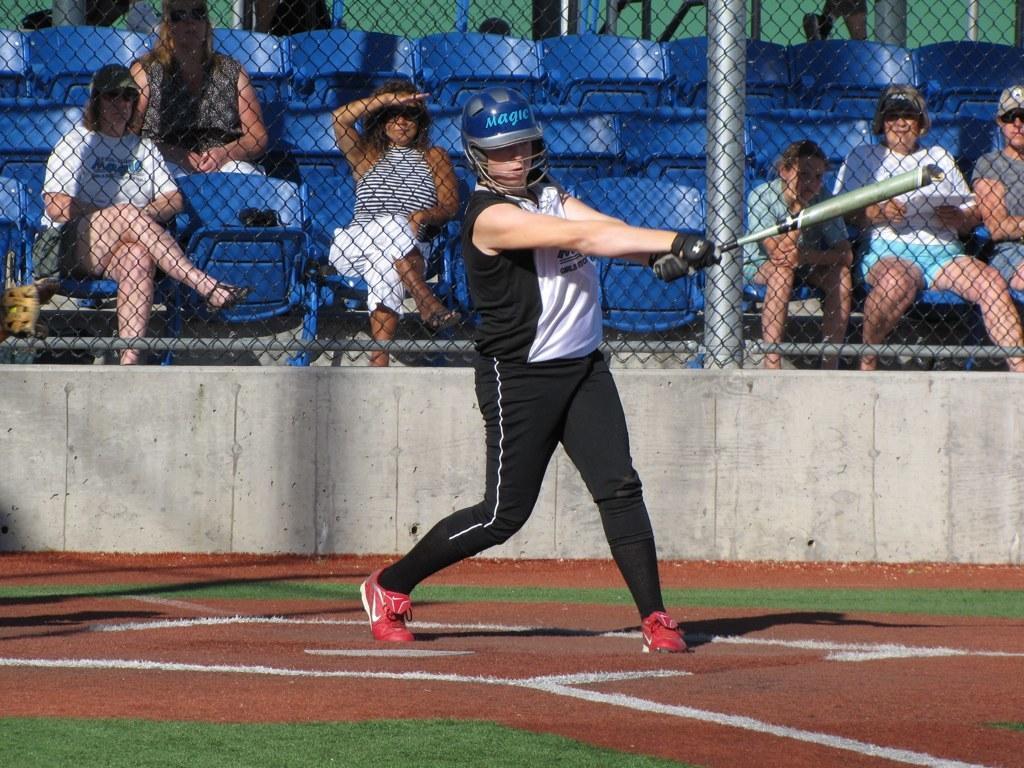How would you summarize this image in a sentence or two? In the image in the center, we can see one person standing and holding a bat. In the background, we can see chairs, few people are sitting and fence. 